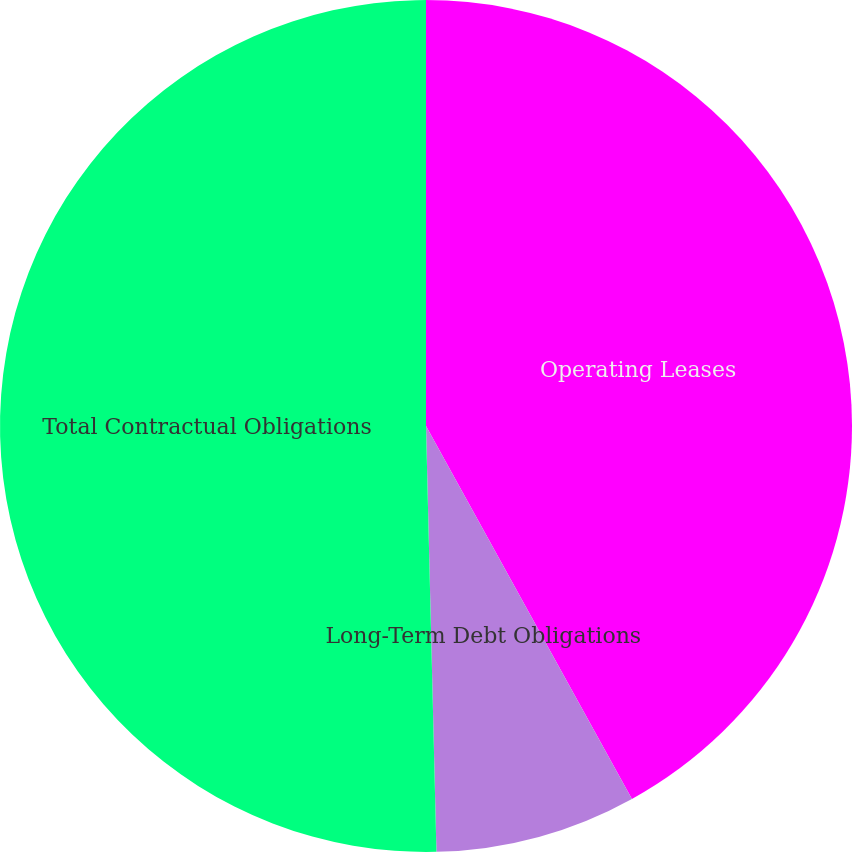Convert chart. <chart><loc_0><loc_0><loc_500><loc_500><pie_chart><fcel>Operating Leases<fcel>Long-Term Debt Obligations<fcel>Total Contractual Obligations<nl><fcel>41.97%<fcel>7.64%<fcel>50.39%<nl></chart> 